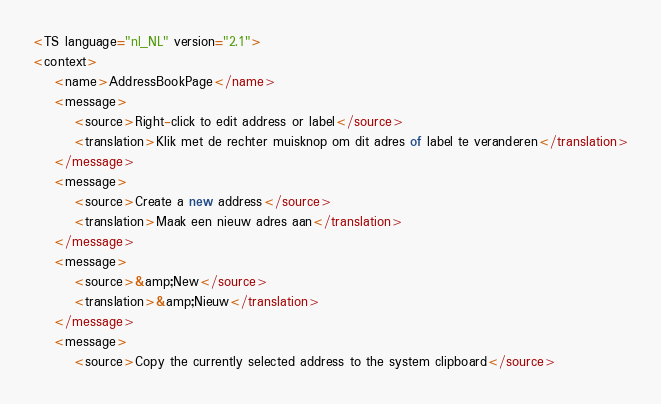<code> <loc_0><loc_0><loc_500><loc_500><_TypeScript_><TS language="nl_NL" version="2.1">
<context>
    <name>AddressBookPage</name>
    <message>
        <source>Right-click to edit address or label</source>
        <translation>Klik met de rechter muisknop om dit adres of label te veranderen</translation>
    </message>
    <message>
        <source>Create a new address</source>
        <translation>Maak een nieuw adres aan</translation>
    </message>
    <message>
        <source>&amp;New</source>
        <translation>&amp;Nieuw</translation>
    </message>
    <message>
        <source>Copy the currently selected address to the system clipboard</source></code> 